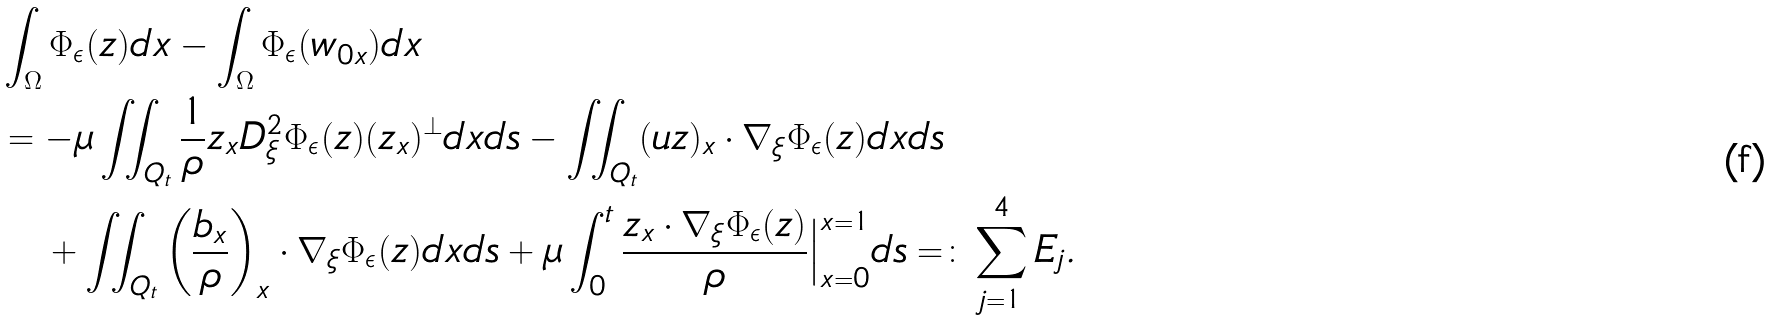<formula> <loc_0><loc_0><loc_500><loc_500>& \int _ { \Omega } \Phi _ { \epsilon } ( z ) d x - \int _ { \Omega } \Phi _ { \epsilon } ( w _ { 0 x } ) d x \\ & = - \mu \iint _ { Q _ { t } } \frac { 1 } { \rho } z _ { x } D _ { \xi } ^ { 2 } \Phi _ { \epsilon } ( z ) ( z _ { x } ) ^ { \perp } d x d s - \iint _ { Q _ { t } } ( u z ) _ { x } \cdot \nabla _ { \xi } \Phi _ { \epsilon } ( z ) d x d s \\ & \quad + \iint _ { Q _ { t } } \left ( \frac { b _ { x } } { \rho } \right ) _ { x } \cdot \nabla _ { \xi } \Phi _ { \epsilon } ( z ) d x d s + \mu \int _ { 0 } ^ { t } \frac { z _ { x } \cdot \nabla _ { \xi } \Phi _ { \epsilon } ( z ) } { \rho } \Big | _ { x = 0 } ^ { x = 1 } d s = \colon \sum _ { j = 1 } ^ { 4 } E _ { j } .</formula> 